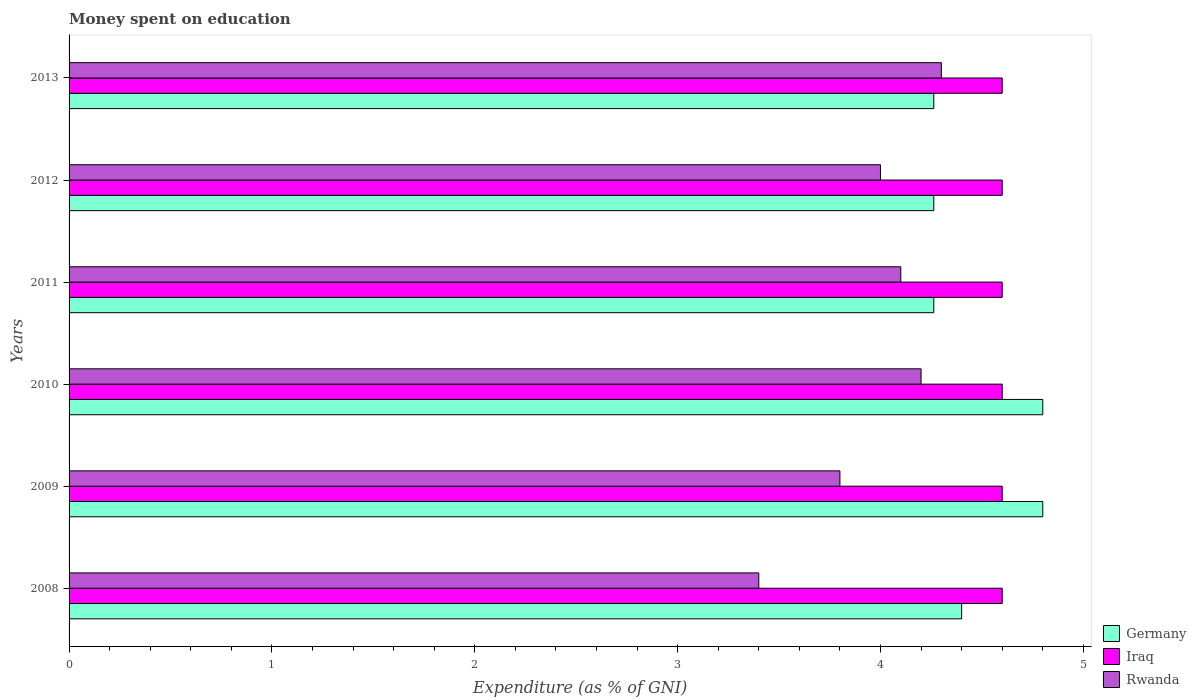Are the number of bars on each tick of the Y-axis equal?
Provide a succinct answer. Yes. How many bars are there on the 6th tick from the top?
Your answer should be very brief. 3. What is the label of the 1st group of bars from the top?
Provide a succinct answer. 2013. In how many cases, is the number of bars for a given year not equal to the number of legend labels?
Provide a succinct answer. 0. What is the amount of money spent on education in Iraq in 2013?
Provide a short and direct response. 4.6. Across all years, what is the minimum amount of money spent on education in Rwanda?
Offer a very short reply. 3.4. What is the total amount of money spent on education in Rwanda in the graph?
Ensure brevity in your answer.  23.8. What is the difference between the amount of money spent on education in Germany in 2008 and that in 2012?
Keep it short and to the point. 0.14. What is the difference between the amount of money spent on education in Germany in 2010 and the amount of money spent on education in Rwanda in 2009?
Provide a succinct answer. 1. What is the average amount of money spent on education in Iraq per year?
Provide a short and direct response. 4.6. In the year 2013, what is the difference between the amount of money spent on education in Iraq and amount of money spent on education in Rwanda?
Ensure brevity in your answer.  0.3. What is the ratio of the amount of money spent on education in Iraq in 2008 to that in 2011?
Offer a very short reply. 1. What is the difference between the highest and the second highest amount of money spent on education in Rwanda?
Provide a short and direct response. 0.1. What is the difference between the highest and the lowest amount of money spent on education in Germany?
Provide a succinct answer. 0.54. Is the sum of the amount of money spent on education in Iraq in 2009 and 2011 greater than the maximum amount of money spent on education in Germany across all years?
Offer a very short reply. Yes. What does the 2nd bar from the top in 2008 represents?
Provide a succinct answer. Iraq. What does the 3rd bar from the bottom in 2013 represents?
Your response must be concise. Rwanda. What is the difference between two consecutive major ticks on the X-axis?
Offer a very short reply. 1. What is the title of the graph?
Your answer should be compact. Money spent on education. What is the label or title of the X-axis?
Make the answer very short. Expenditure (as % of GNI). What is the Expenditure (as % of GNI) in Rwanda in 2008?
Make the answer very short. 3.4. What is the Expenditure (as % of GNI) in Germany in 2009?
Provide a succinct answer. 4.8. What is the Expenditure (as % of GNI) in Iraq in 2009?
Offer a very short reply. 4.6. What is the Expenditure (as % of GNI) of Rwanda in 2009?
Your answer should be very brief. 3.8. What is the Expenditure (as % of GNI) of Germany in 2010?
Give a very brief answer. 4.8. What is the Expenditure (as % of GNI) in Iraq in 2010?
Ensure brevity in your answer.  4.6. What is the Expenditure (as % of GNI) in Germany in 2011?
Offer a terse response. 4.26. What is the Expenditure (as % of GNI) of Germany in 2012?
Provide a succinct answer. 4.26. What is the Expenditure (as % of GNI) of Iraq in 2012?
Your response must be concise. 4.6. What is the Expenditure (as % of GNI) in Germany in 2013?
Provide a short and direct response. 4.26. Across all years, what is the minimum Expenditure (as % of GNI) of Germany?
Your response must be concise. 4.26. Across all years, what is the minimum Expenditure (as % of GNI) of Rwanda?
Your answer should be compact. 3.4. What is the total Expenditure (as % of GNI) of Germany in the graph?
Make the answer very short. 26.79. What is the total Expenditure (as % of GNI) of Iraq in the graph?
Keep it short and to the point. 27.6. What is the total Expenditure (as % of GNI) in Rwanda in the graph?
Provide a succinct answer. 23.8. What is the difference between the Expenditure (as % of GNI) in Iraq in 2008 and that in 2009?
Your response must be concise. 0. What is the difference between the Expenditure (as % of GNI) of Iraq in 2008 and that in 2010?
Provide a short and direct response. 0. What is the difference between the Expenditure (as % of GNI) in Germany in 2008 and that in 2011?
Keep it short and to the point. 0.14. What is the difference between the Expenditure (as % of GNI) of Rwanda in 2008 and that in 2011?
Your answer should be compact. -0.7. What is the difference between the Expenditure (as % of GNI) in Germany in 2008 and that in 2012?
Ensure brevity in your answer.  0.14. What is the difference between the Expenditure (as % of GNI) of Germany in 2008 and that in 2013?
Your answer should be very brief. 0.14. What is the difference between the Expenditure (as % of GNI) in Iraq in 2008 and that in 2013?
Give a very brief answer. 0. What is the difference between the Expenditure (as % of GNI) of Rwanda in 2008 and that in 2013?
Your response must be concise. -0.9. What is the difference between the Expenditure (as % of GNI) in Germany in 2009 and that in 2011?
Provide a short and direct response. 0.54. What is the difference between the Expenditure (as % of GNI) of Germany in 2009 and that in 2012?
Ensure brevity in your answer.  0.54. What is the difference between the Expenditure (as % of GNI) in Iraq in 2009 and that in 2012?
Offer a very short reply. 0. What is the difference between the Expenditure (as % of GNI) of Germany in 2009 and that in 2013?
Provide a short and direct response. 0.54. What is the difference between the Expenditure (as % of GNI) of Iraq in 2009 and that in 2013?
Offer a terse response. 0. What is the difference between the Expenditure (as % of GNI) in Rwanda in 2009 and that in 2013?
Provide a short and direct response. -0.5. What is the difference between the Expenditure (as % of GNI) of Germany in 2010 and that in 2011?
Your response must be concise. 0.54. What is the difference between the Expenditure (as % of GNI) of Iraq in 2010 and that in 2011?
Provide a short and direct response. 0. What is the difference between the Expenditure (as % of GNI) in Rwanda in 2010 and that in 2011?
Provide a succinct answer. 0.1. What is the difference between the Expenditure (as % of GNI) of Germany in 2010 and that in 2012?
Give a very brief answer. 0.54. What is the difference between the Expenditure (as % of GNI) of Germany in 2010 and that in 2013?
Provide a short and direct response. 0.54. What is the difference between the Expenditure (as % of GNI) in Iraq in 2010 and that in 2013?
Ensure brevity in your answer.  0. What is the difference between the Expenditure (as % of GNI) of Rwanda in 2010 and that in 2013?
Ensure brevity in your answer.  -0.1. What is the difference between the Expenditure (as % of GNI) in Germany in 2011 and that in 2012?
Ensure brevity in your answer.  0. What is the difference between the Expenditure (as % of GNI) in Iraq in 2011 and that in 2012?
Provide a succinct answer. 0. What is the difference between the Expenditure (as % of GNI) in Rwanda in 2011 and that in 2012?
Your response must be concise. 0.1. What is the difference between the Expenditure (as % of GNI) in Germany in 2011 and that in 2013?
Provide a short and direct response. 0. What is the difference between the Expenditure (as % of GNI) in Iraq in 2012 and that in 2013?
Your answer should be very brief. 0. What is the difference between the Expenditure (as % of GNI) of Germany in 2008 and the Expenditure (as % of GNI) of Iraq in 2010?
Ensure brevity in your answer.  -0.2. What is the difference between the Expenditure (as % of GNI) in Iraq in 2008 and the Expenditure (as % of GNI) in Rwanda in 2010?
Your answer should be compact. 0.4. What is the difference between the Expenditure (as % of GNI) of Germany in 2008 and the Expenditure (as % of GNI) of Rwanda in 2011?
Provide a short and direct response. 0.3. What is the difference between the Expenditure (as % of GNI) in Iraq in 2008 and the Expenditure (as % of GNI) in Rwanda in 2011?
Your answer should be compact. 0.5. What is the difference between the Expenditure (as % of GNI) in Germany in 2008 and the Expenditure (as % of GNI) in Iraq in 2012?
Ensure brevity in your answer.  -0.2. What is the difference between the Expenditure (as % of GNI) in Iraq in 2008 and the Expenditure (as % of GNI) in Rwanda in 2012?
Your answer should be very brief. 0.6. What is the difference between the Expenditure (as % of GNI) of Germany in 2008 and the Expenditure (as % of GNI) of Iraq in 2013?
Offer a terse response. -0.2. What is the difference between the Expenditure (as % of GNI) of Germany in 2008 and the Expenditure (as % of GNI) of Rwanda in 2013?
Offer a terse response. 0.1. What is the difference between the Expenditure (as % of GNI) of Germany in 2009 and the Expenditure (as % of GNI) of Iraq in 2010?
Give a very brief answer. 0.2. What is the difference between the Expenditure (as % of GNI) of Germany in 2009 and the Expenditure (as % of GNI) of Rwanda in 2012?
Offer a very short reply. 0.8. What is the difference between the Expenditure (as % of GNI) of Germany in 2009 and the Expenditure (as % of GNI) of Iraq in 2013?
Make the answer very short. 0.2. What is the difference between the Expenditure (as % of GNI) in Germany in 2009 and the Expenditure (as % of GNI) in Rwanda in 2013?
Your answer should be very brief. 0.5. What is the difference between the Expenditure (as % of GNI) of Germany in 2010 and the Expenditure (as % of GNI) of Iraq in 2011?
Provide a short and direct response. 0.2. What is the difference between the Expenditure (as % of GNI) of Germany in 2010 and the Expenditure (as % of GNI) of Rwanda in 2011?
Your answer should be compact. 0.7. What is the difference between the Expenditure (as % of GNI) in Iraq in 2010 and the Expenditure (as % of GNI) in Rwanda in 2011?
Your response must be concise. 0.5. What is the difference between the Expenditure (as % of GNI) of Germany in 2010 and the Expenditure (as % of GNI) of Rwanda in 2012?
Ensure brevity in your answer.  0.8. What is the difference between the Expenditure (as % of GNI) of Iraq in 2010 and the Expenditure (as % of GNI) of Rwanda in 2012?
Keep it short and to the point. 0.6. What is the difference between the Expenditure (as % of GNI) in Germany in 2010 and the Expenditure (as % of GNI) in Iraq in 2013?
Your response must be concise. 0.2. What is the difference between the Expenditure (as % of GNI) of Germany in 2010 and the Expenditure (as % of GNI) of Rwanda in 2013?
Your answer should be compact. 0.5. What is the difference between the Expenditure (as % of GNI) of Iraq in 2010 and the Expenditure (as % of GNI) of Rwanda in 2013?
Your answer should be very brief. 0.3. What is the difference between the Expenditure (as % of GNI) in Germany in 2011 and the Expenditure (as % of GNI) in Iraq in 2012?
Give a very brief answer. -0.34. What is the difference between the Expenditure (as % of GNI) in Germany in 2011 and the Expenditure (as % of GNI) in Rwanda in 2012?
Your answer should be compact. 0.26. What is the difference between the Expenditure (as % of GNI) of Germany in 2011 and the Expenditure (as % of GNI) of Iraq in 2013?
Offer a very short reply. -0.34. What is the difference between the Expenditure (as % of GNI) in Germany in 2011 and the Expenditure (as % of GNI) in Rwanda in 2013?
Offer a very short reply. -0.04. What is the difference between the Expenditure (as % of GNI) in Iraq in 2011 and the Expenditure (as % of GNI) in Rwanda in 2013?
Give a very brief answer. 0.3. What is the difference between the Expenditure (as % of GNI) of Germany in 2012 and the Expenditure (as % of GNI) of Iraq in 2013?
Offer a very short reply. -0.34. What is the difference between the Expenditure (as % of GNI) of Germany in 2012 and the Expenditure (as % of GNI) of Rwanda in 2013?
Ensure brevity in your answer.  -0.04. What is the average Expenditure (as % of GNI) of Germany per year?
Offer a very short reply. 4.46. What is the average Expenditure (as % of GNI) of Iraq per year?
Your response must be concise. 4.6. What is the average Expenditure (as % of GNI) in Rwanda per year?
Your answer should be very brief. 3.97. In the year 2008, what is the difference between the Expenditure (as % of GNI) in Germany and Expenditure (as % of GNI) in Iraq?
Provide a succinct answer. -0.2. In the year 2008, what is the difference between the Expenditure (as % of GNI) in Iraq and Expenditure (as % of GNI) in Rwanda?
Give a very brief answer. 1.2. In the year 2009, what is the difference between the Expenditure (as % of GNI) of Germany and Expenditure (as % of GNI) of Rwanda?
Give a very brief answer. 1. In the year 2009, what is the difference between the Expenditure (as % of GNI) in Iraq and Expenditure (as % of GNI) in Rwanda?
Your response must be concise. 0.8. In the year 2010, what is the difference between the Expenditure (as % of GNI) of Germany and Expenditure (as % of GNI) of Iraq?
Offer a very short reply. 0.2. In the year 2010, what is the difference between the Expenditure (as % of GNI) of Germany and Expenditure (as % of GNI) of Rwanda?
Your response must be concise. 0.6. In the year 2011, what is the difference between the Expenditure (as % of GNI) of Germany and Expenditure (as % of GNI) of Iraq?
Ensure brevity in your answer.  -0.34. In the year 2011, what is the difference between the Expenditure (as % of GNI) in Germany and Expenditure (as % of GNI) in Rwanda?
Offer a terse response. 0.16. In the year 2011, what is the difference between the Expenditure (as % of GNI) of Iraq and Expenditure (as % of GNI) of Rwanda?
Ensure brevity in your answer.  0.5. In the year 2012, what is the difference between the Expenditure (as % of GNI) of Germany and Expenditure (as % of GNI) of Iraq?
Ensure brevity in your answer.  -0.34. In the year 2012, what is the difference between the Expenditure (as % of GNI) of Germany and Expenditure (as % of GNI) of Rwanda?
Provide a succinct answer. 0.26. In the year 2012, what is the difference between the Expenditure (as % of GNI) of Iraq and Expenditure (as % of GNI) of Rwanda?
Your answer should be compact. 0.6. In the year 2013, what is the difference between the Expenditure (as % of GNI) of Germany and Expenditure (as % of GNI) of Iraq?
Give a very brief answer. -0.34. In the year 2013, what is the difference between the Expenditure (as % of GNI) in Germany and Expenditure (as % of GNI) in Rwanda?
Offer a terse response. -0.04. In the year 2013, what is the difference between the Expenditure (as % of GNI) in Iraq and Expenditure (as % of GNI) in Rwanda?
Offer a terse response. 0.3. What is the ratio of the Expenditure (as % of GNI) in Rwanda in 2008 to that in 2009?
Offer a very short reply. 0.89. What is the ratio of the Expenditure (as % of GNI) in Rwanda in 2008 to that in 2010?
Make the answer very short. 0.81. What is the ratio of the Expenditure (as % of GNI) in Germany in 2008 to that in 2011?
Offer a terse response. 1.03. What is the ratio of the Expenditure (as % of GNI) of Rwanda in 2008 to that in 2011?
Offer a terse response. 0.83. What is the ratio of the Expenditure (as % of GNI) of Germany in 2008 to that in 2012?
Offer a very short reply. 1.03. What is the ratio of the Expenditure (as % of GNI) of Germany in 2008 to that in 2013?
Offer a terse response. 1.03. What is the ratio of the Expenditure (as % of GNI) in Rwanda in 2008 to that in 2013?
Keep it short and to the point. 0.79. What is the ratio of the Expenditure (as % of GNI) of Rwanda in 2009 to that in 2010?
Your answer should be compact. 0.9. What is the ratio of the Expenditure (as % of GNI) in Germany in 2009 to that in 2011?
Ensure brevity in your answer.  1.13. What is the ratio of the Expenditure (as % of GNI) in Iraq in 2009 to that in 2011?
Give a very brief answer. 1. What is the ratio of the Expenditure (as % of GNI) of Rwanda in 2009 to that in 2011?
Keep it short and to the point. 0.93. What is the ratio of the Expenditure (as % of GNI) of Germany in 2009 to that in 2012?
Keep it short and to the point. 1.13. What is the ratio of the Expenditure (as % of GNI) in Germany in 2009 to that in 2013?
Your answer should be very brief. 1.13. What is the ratio of the Expenditure (as % of GNI) of Rwanda in 2009 to that in 2013?
Give a very brief answer. 0.88. What is the ratio of the Expenditure (as % of GNI) of Germany in 2010 to that in 2011?
Make the answer very short. 1.13. What is the ratio of the Expenditure (as % of GNI) in Rwanda in 2010 to that in 2011?
Offer a very short reply. 1.02. What is the ratio of the Expenditure (as % of GNI) of Germany in 2010 to that in 2012?
Offer a very short reply. 1.13. What is the ratio of the Expenditure (as % of GNI) in Germany in 2010 to that in 2013?
Your response must be concise. 1.13. What is the ratio of the Expenditure (as % of GNI) in Rwanda in 2010 to that in 2013?
Offer a very short reply. 0.98. What is the ratio of the Expenditure (as % of GNI) of Iraq in 2011 to that in 2013?
Provide a succinct answer. 1. What is the ratio of the Expenditure (as % of GNI) in Rwanda in 2011 to that in 2013?
Offer a terse response. 0.95. What is the ratio of the Expenditure (as % of GNI) of Rwanda in 2012 to that in 2013?
Make the answer very short. 0.93. What is the difference between the highest and the second highest Expenditure (as % of GNI) of Germany?
Keep it short and to the point. 0. What is the difference between the highest and the second highest Expenditure (as % of GNI) of Iraq?
Provide a short and direct response. 0. What is the difference between the highest and the lowest Expenditure (as % of GNI) of Germany?
Keep it short and to the point. 0.54. What is the difference between the highest and the lowest Expenditure (as % of GNI) in Iraq?
Your answer should be compact. 0. What is the difference between the highest and the lowest Expenditure (as % of GNI) in Rwanda?
Your answer should be compact. 0.9. 